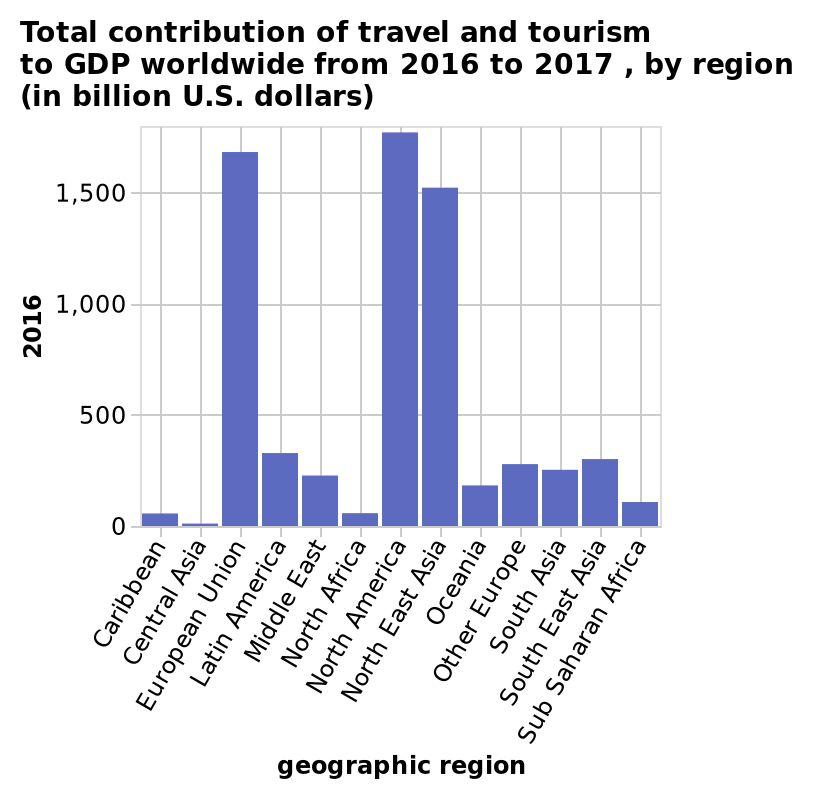<image>
Among the mentioned regions, which region has the highest contribution of travel and tourism to GDP? North America has the highest contribution of travel and tourism to GDP. Which region has the lowest contribution of travel and tourism to GDP?  Central Asia has the lowest contribution of travel and tourism to GDP. Does Central Asia have the highest contribution of travel and tourism to GDP? No. Central Asia has the lowest contribution of travel and tourism to GDP. 